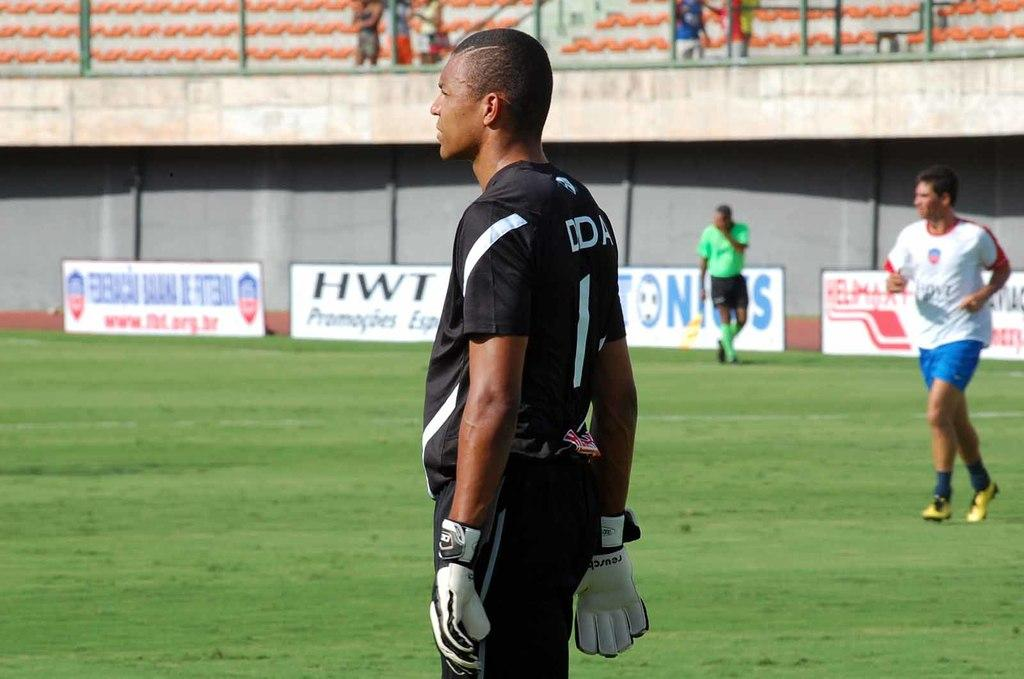<image>
Give a short and clear explanation of the subsequent image. Soccer players are on a field that has a banner HWT in the background. 